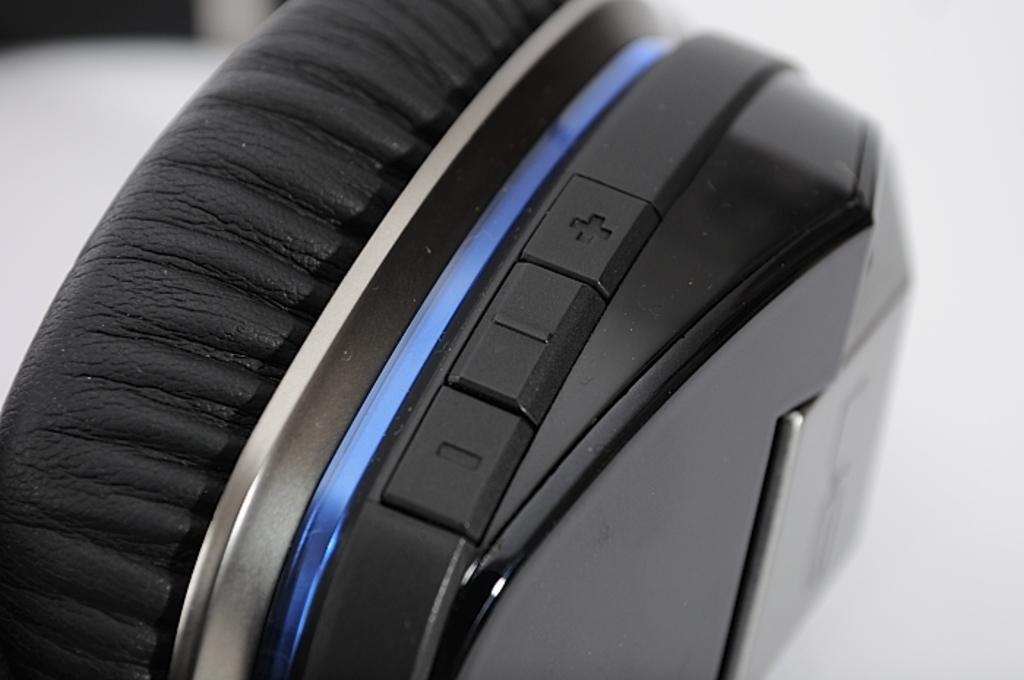What is the main object in the image? There is a headphone in the image. How many rats are sitting on the headphone in the image? There are no rats present in the image; it only features a headphone. What type of glass is used to make the headphone in the image? The image does not provide information about the materials used to make the headphone, so it cannot be determined from the image. 